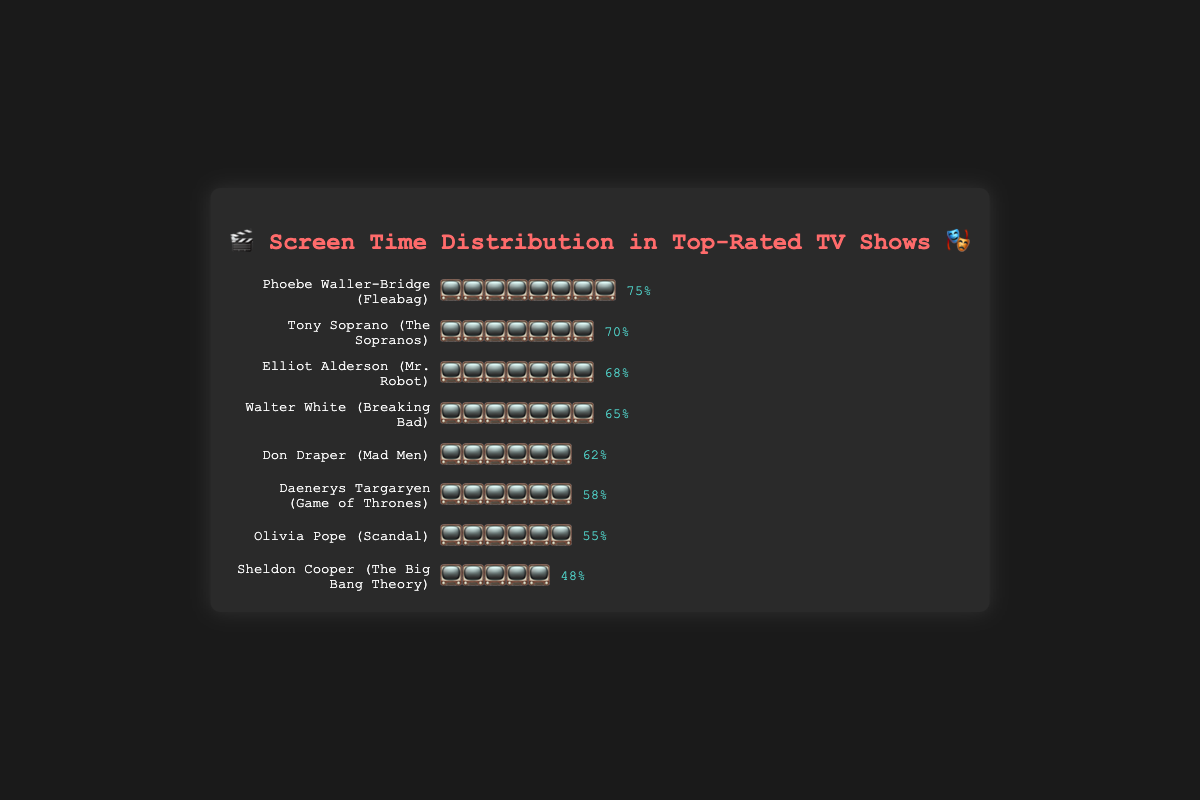Which character has the most screen time? The character with the most emojis representing screen time is Phoebe Waller-Bridge from Fleabag. The bar has eight 📺 emojis and 75% written next to it.
Answer: Phoebe Waller-Bridge What is the screen time percentage for Sheldon Cooper? The bar for Sheldon Cooper has five 📺 emojis, which corresponds to 48%, as written to the right of the bar.
Answer: 48% Which show has characters with screen time above 70%? Tony Soprano from The Sopranos has 70% screen time. Phoebe Waller-Bridge from Fleabag has 75% screen time.
Answer: The Sopranos, Fleabag Compare the screen time of Walter White and Don Draper. Walter White has seven 📺 emojis representing 65% screen time, while Don Draper has six 📺 emojis representing 62% screen time. Walter White has more screen time.
Answer: Walter White Calculate the average screen time of all characters in the chart. Sum of percentages (75 + 70 + 68 + 65 + 62 + 58 + 55 + 48) = 501. Number of characters is 8. Average screen time = 501/8 = 62.625%
Answer: 62.625% How much more screen time does Elliot Alderson have compared to Olivia Pope? Elliot Alderson has 68% screen time, and Olivia Pope has 55%. The difference is 68% - 55% = 13%.
Answer: 13% List characters with screen time between 50% and 60%. Daenerys Targaryen (58%), Olivia Pope (55%) fall within this range according to their respective emoji bars and percentages.
Answer: Daenerys Targaryen, Olivia Pope Who has more screen time, Daenerys Targaryen or Sheldon Cooper? The bar for Daenerys Targaryen has six 📺 emojis (58%), while Sheldon Cooper's bar has five 📺 emojis (48%). Daenerys Targaryen has more screen time.
Answer: Daenerys Targaryen Explain why Phoebe Waller-Bridge's bar is the longest. Phoebe Waller-Bridge's bar has the most 📺 emojis (eight), indicating she has the highest screen time percentage (75%) among all characters in the chart, making her bar the longest.
Answer: She has the highest screen time Who are the top three characters in terms of screen time? The top three bars, based on the number of 📺 emojis and percentages, belong to Phoebe Waller-Bridge (75%), Tony Soprano (70%), and Elliot Alderson (68%).
Answer: Phoebe Waller-Bridge, Tony Soprano, Elliot Alderson 